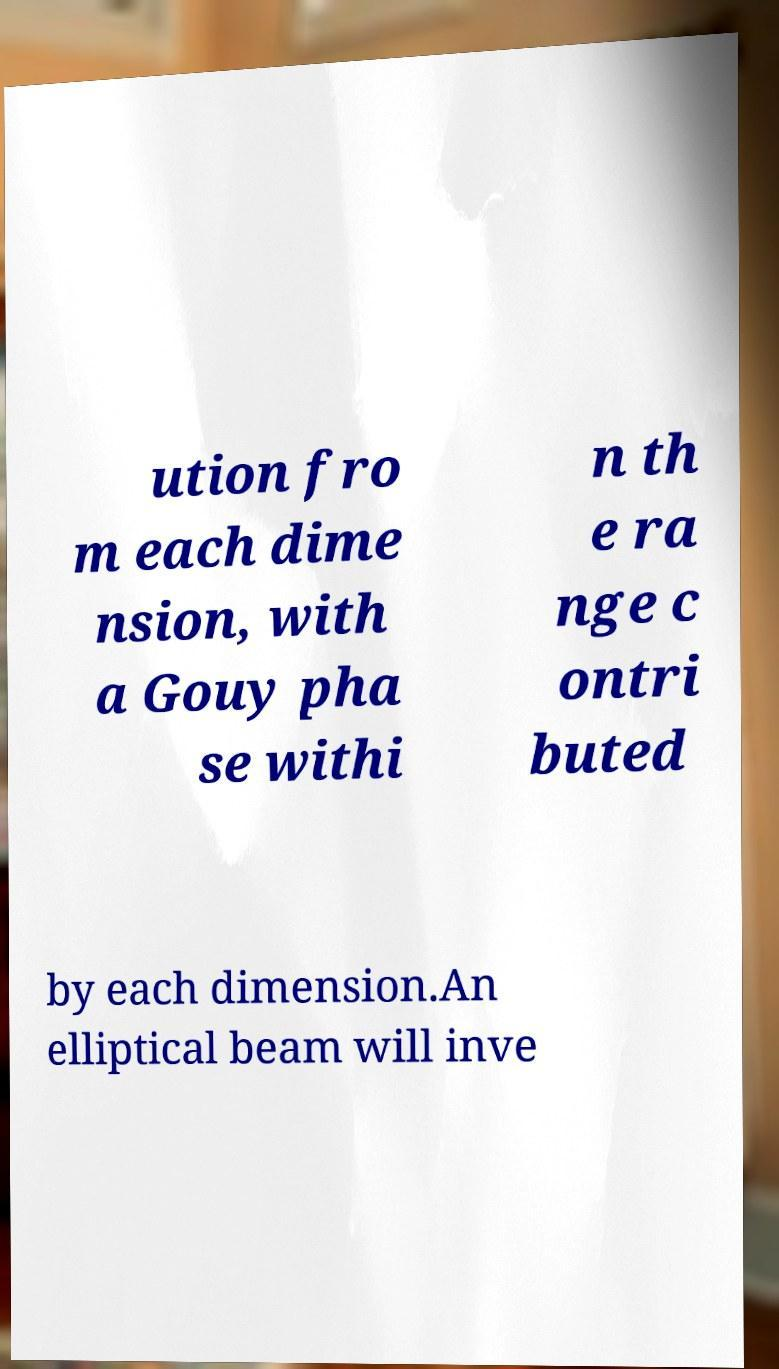Could you assist in decoding the text presented in this image and type it out clearly? ution fro m each dime nsion, with a Gouy pha se withi n th e ra nge c ontri buted by each dimension.An elliptical beam will inve 